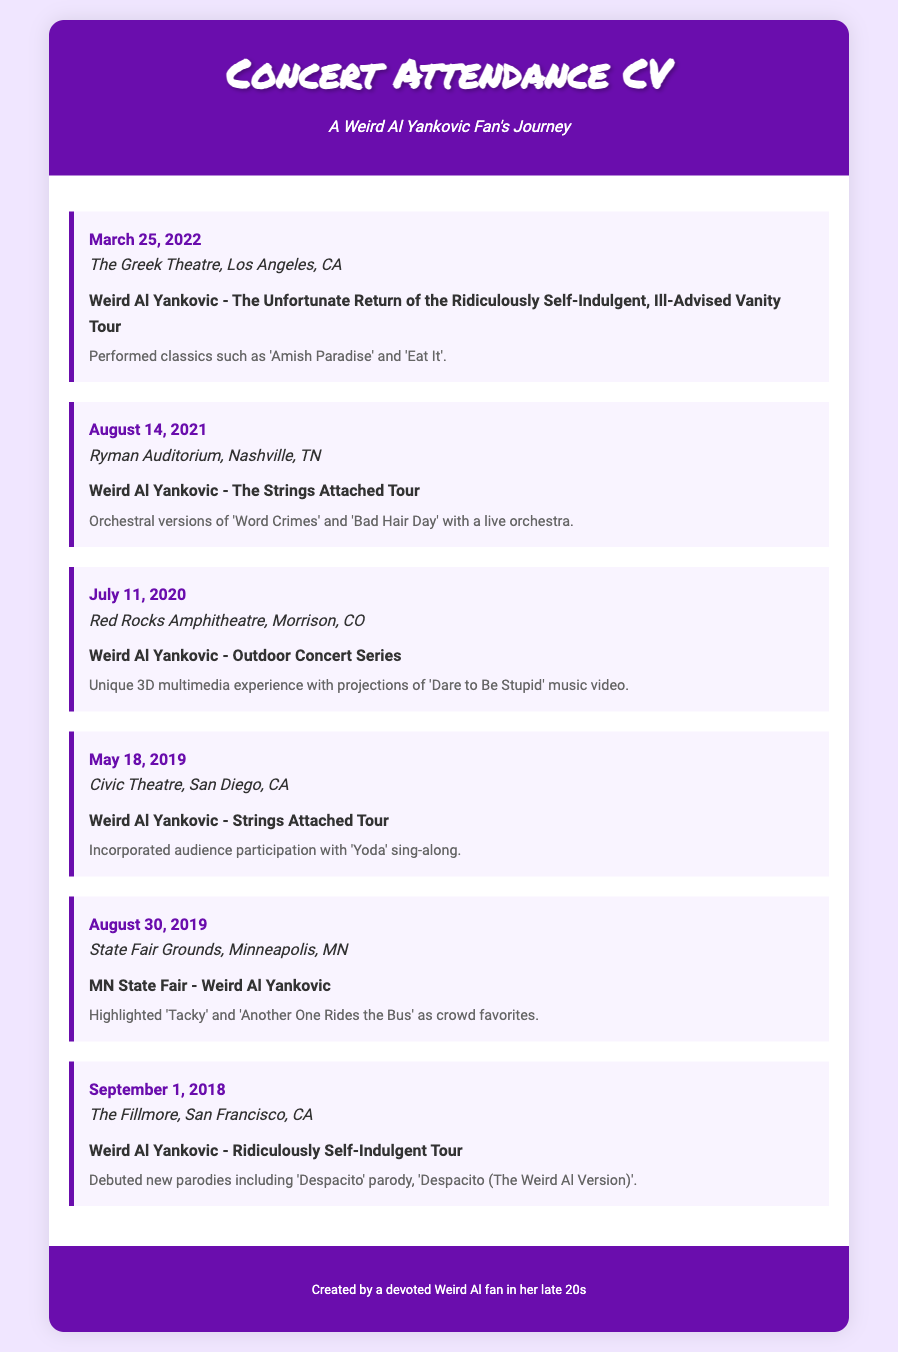What was the last concert attended? The last concert listed in the document is on March 25, 2022.
Answer: March 25, 2022 Who performed at the Ryman Auditorium? The document mentions the performer for the August 14, 2021 concert was Weird Al Yankovic.
Answer: Weird Al Yankovic Which venue hosted a concert on May 18, 2019? The venue for the concert on that date is specified in the document as Civic Theatre.
Answer: Civic Theatre What notable song was performed during the 2019 concert at the State Fair Grounds? The document states that 'Tacky' was highlighted as a crowd favorite during that concert.
Answer: Tacky How many concerts are listed in total? The document presents a list of concerts attended, which counts to six entries.
Answer: Six What tour was featured during the concert on September 1, 2018? The document references the Ridiculously Self-Indulgent Tour as the performance for that date.
Answer: Ridiculously Self-Indulgent Tour Which concert included audience participation with a sing-along? The concert on May 18, 2019 is noted for having audience participation with 'Yoda' sing-along.
Answer: Yoda What notable experience was highlighted during the concert at Red Rocks Amphitheatre? The document mentions a unique 3D multimedia experience during the concert.
Answer: 3D multimedia experience 